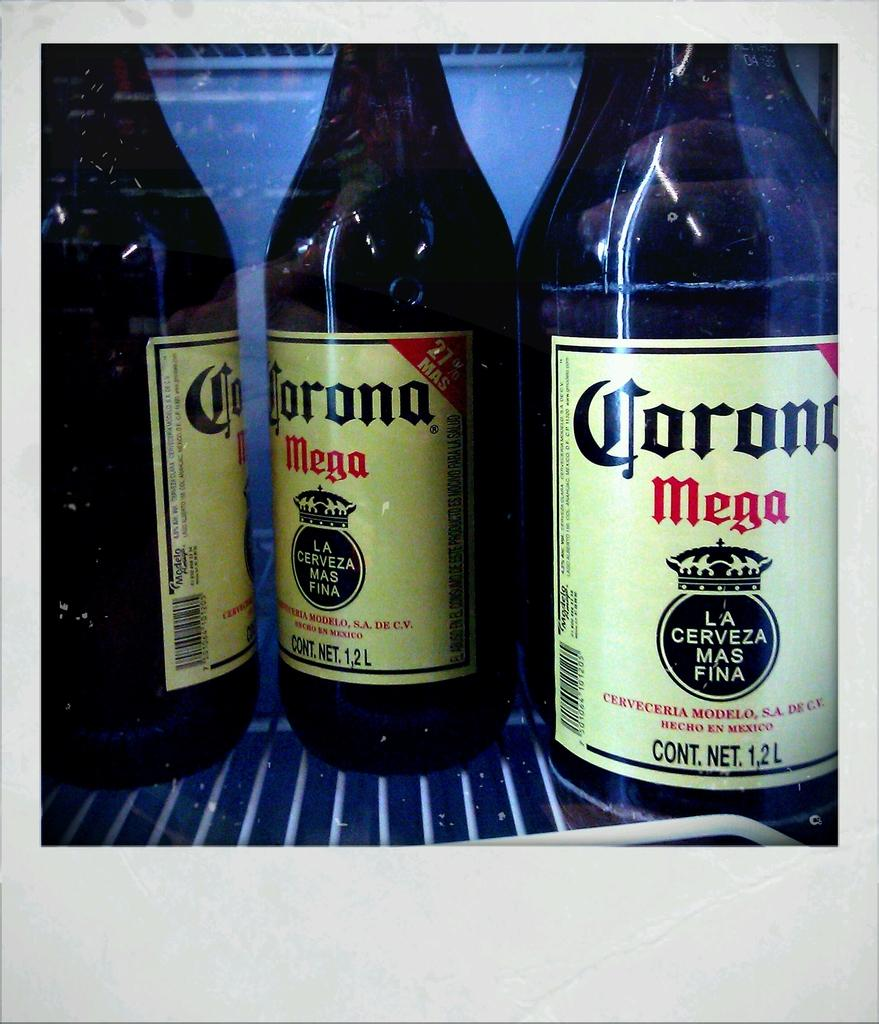<image>
Write a terse but informative summary of the picture. Bottles of Corona Mega states it is La Cerveza mas fina. 